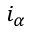<formula> <loc_0><loc_0><loc_500><loc_500>i _ { \alpha }</formula> 